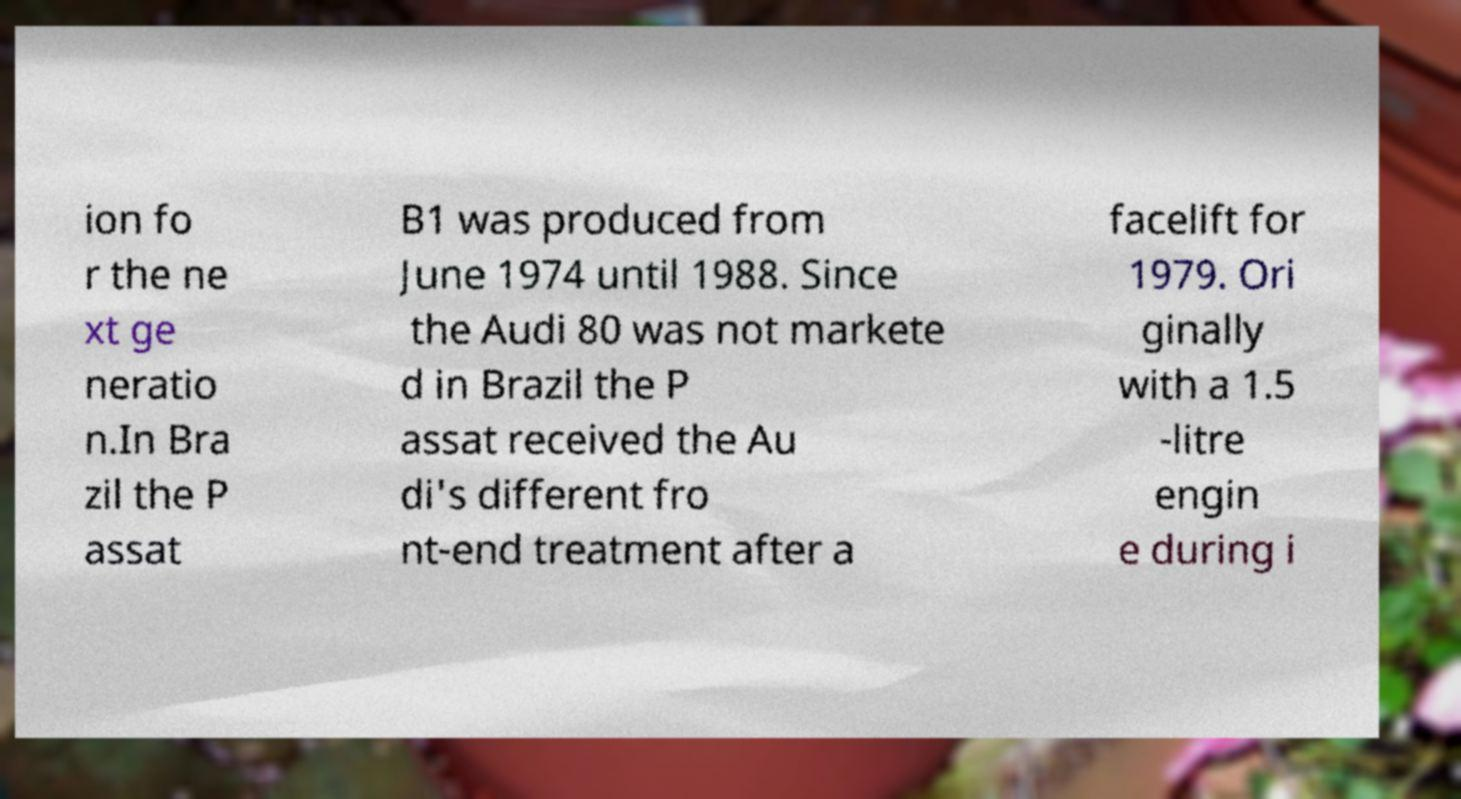Could you assist in decoding the text presented in this image and type it out clearly? ion fo r the ne xt ge neratio n.In Bra zil the P assat B1 was produced from June 1974 until 1988. Since the Audi 80 was not markete d in Brazil the P assat received the Au di's different fro nt-end treatment after a facelift for 1979. Ori ginally with a 1.5 -litre engin e during i 